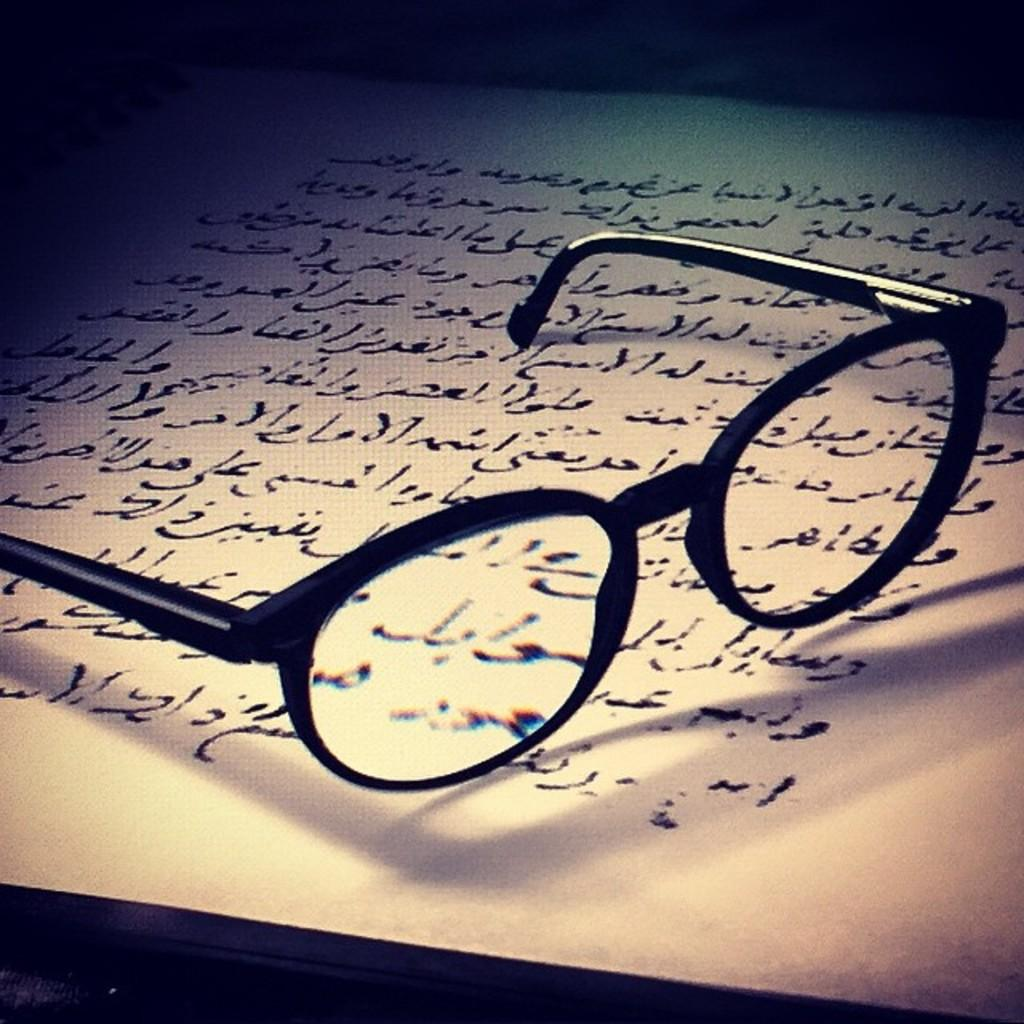What is on the paper that is visible in the image? There is text on the paper in the image. What object is placed on the paper? There are spectacles on the paper. How many trees can be seen in the image? There are no trees visible in the image; it only features a paper with text and spectacles on it. 